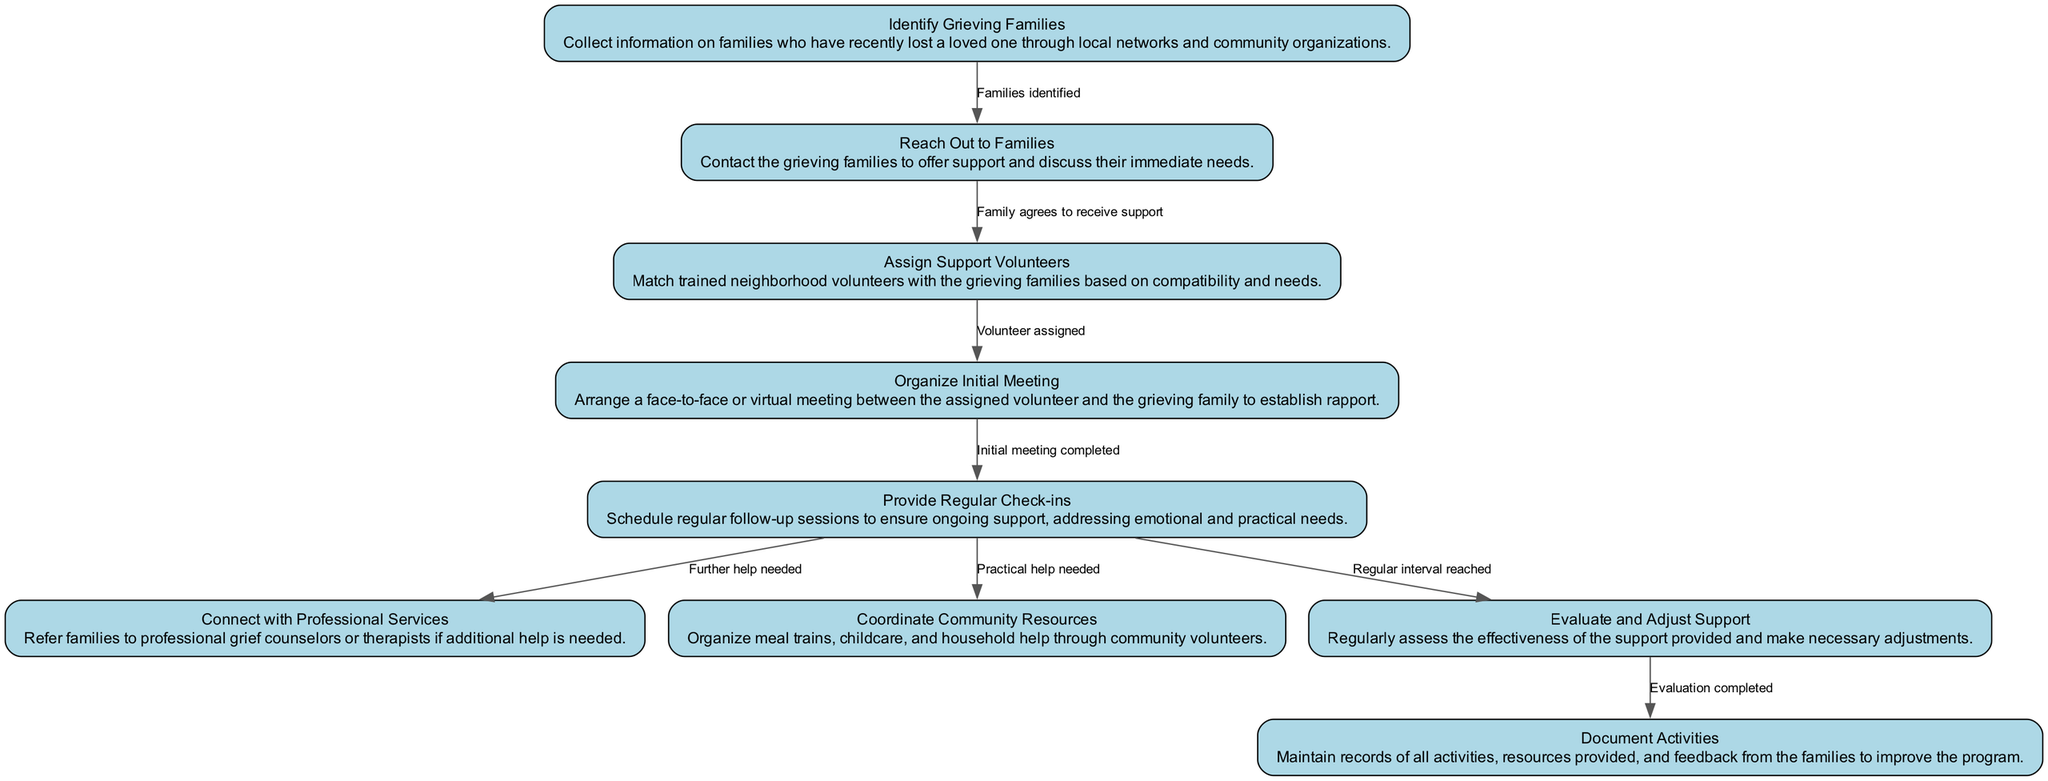What is the first activity in the diagram? The first activity in the diagram is "Identify Grieving Families". This is indicated as the starting point of the flow in the diagram, which represents the beginning of the neighbor-to-neighbor support program.
Answer: Identify Grieving Families How many activities are listed in the diagram? By counting the defined activities in the diagram, there are a total of nine activities. Each activity is represented as a node in the diagram, and after reviewing the list, we confirm that there are nine distinct activities.
Answer: 9 What is the last step after "Evaluate and Adjust Support"? The last step following "Evaluate and Adjust Support" is "Document Activities". The arrow connecting these two nodes indicates that once the evaluation is completed, the next action taken is to document these activities.
Answer: Document Activities What condition leads from "Reach Out to Families" to "Assign Support Volunteers"? The condition leading from "Reach Out to Families" to "Assign Support Volunteers" is "Family agrees to receive support". This condition is necessary for the transition to ensure that there is a willingness from the family to accept help.
Answer: Family agrees to receive support Which two activities can follow "Provide Regular Check-ins"? After "Provide Regular Check-ins", the two activities that can follow are "Connect with Professional Services" and "Coordinate Community Resources". These activities depend on the needs identified during the regular check-ins.
Answer: Connect with Professional Services, Coordinate Community Resources What flow of activities occurs after "Organize Initial Meeting"? After "Organize Initial Meeting", the flow of activities follows to "Provide Regular Check-ins". This indicates that once the initial rapport is established, ongoing support sessions are implemented.
Answer: Provide Regular Check-ins What does the transition "from Provide Regular Check-ins to Evaluate and Adjust Support" depend on? This transition depends on the condition "Regular interval reached". This implies that the regular follow-ups are necessary to assess and adjust the ongoing support provided to the grieving families.
Answer: Regular interval reached 